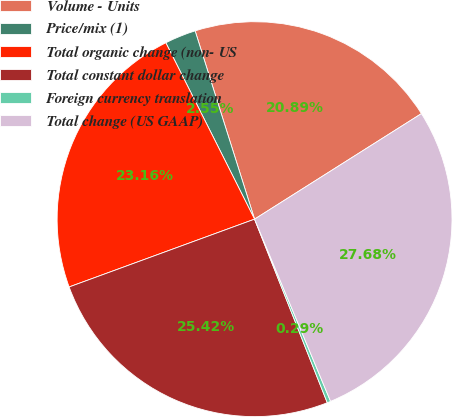Convert chart. <chart><loc_0><loc_0><loc_500><loc_500><pie_chart><fcel>Volume - Units<fcel>Price/mix (1)<fcel>Total organic change (non- US<fcel>Total constant dollar change<fcel>Foreign currency translation<fcel>Total change (US GAAP)<nl><fcel>20.89%<fcel>2.55%<fcel>23.16%<fcel>25.42%<fcel>0.29%<fcel>27.68%<nl></chart> 